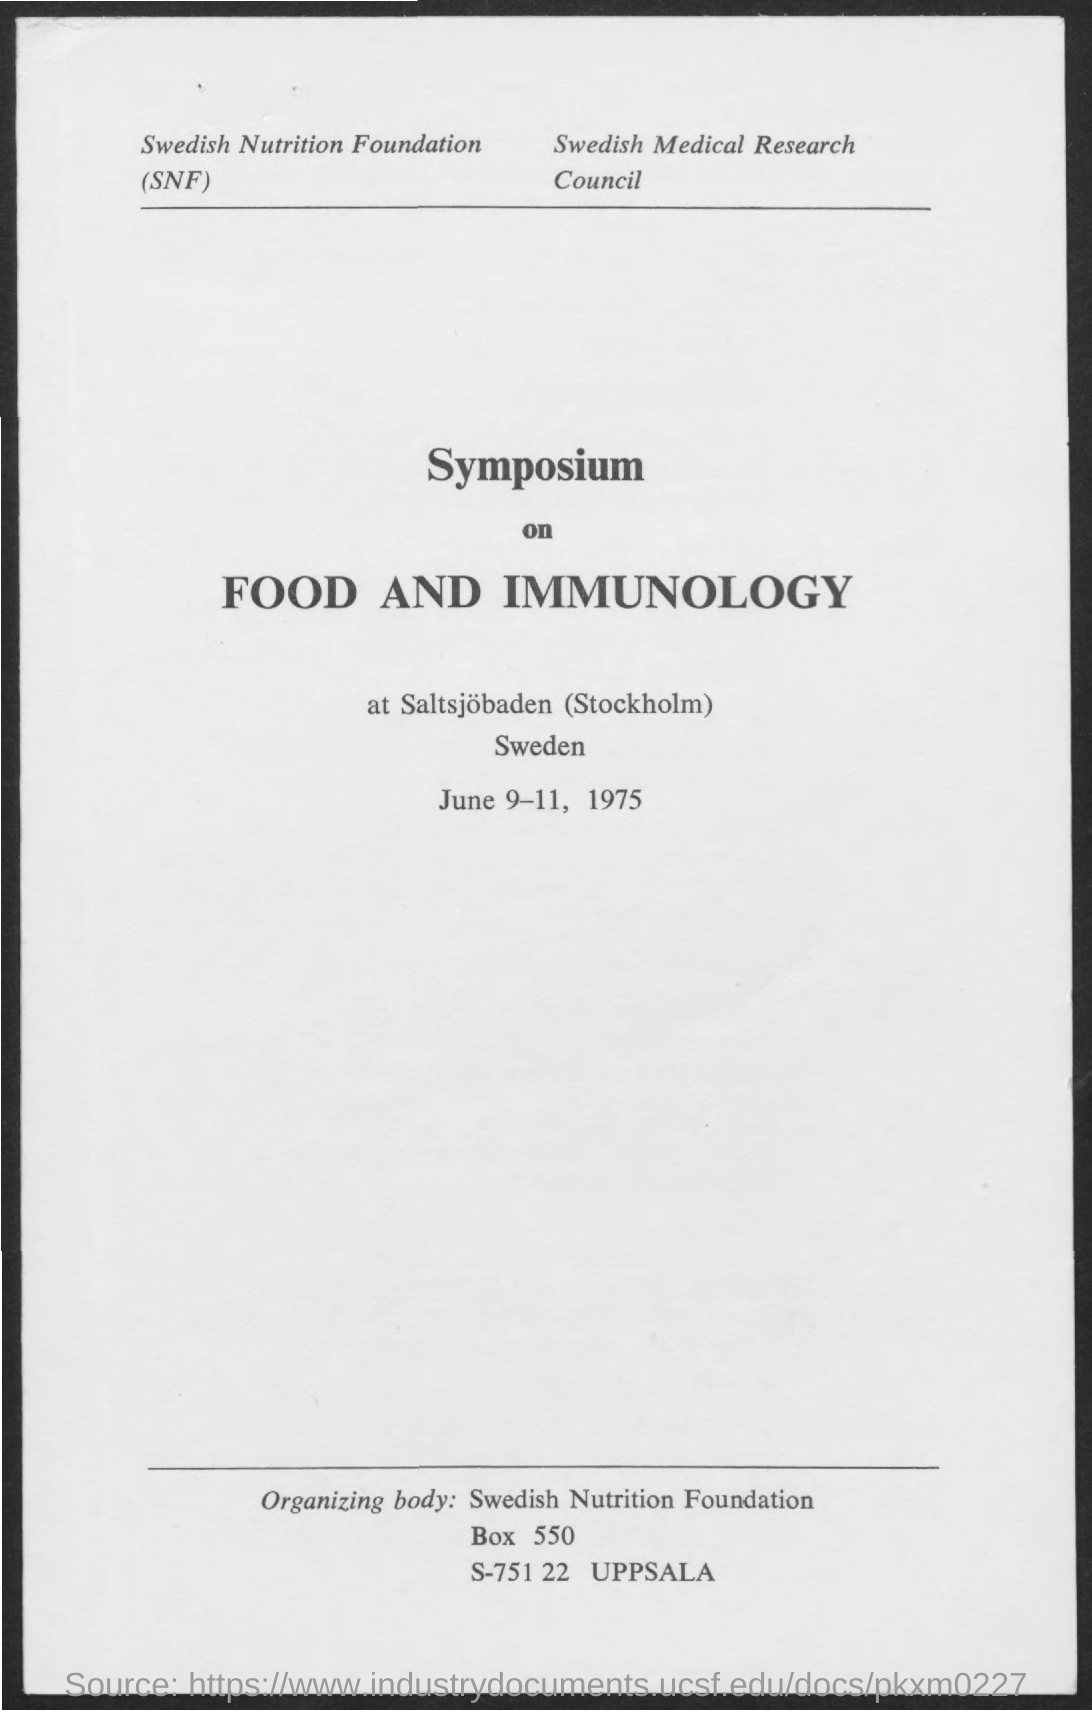Highlight a few significant elements in this photo. The given symposium focuses on the interrelation between food and immunology. The date mentioned in the given page is June 9-11, 1975. The full form of SNF is the Swedish Nutrition Foundation. The Swedish Medical Research Council is the name of the council that was mentioned. 